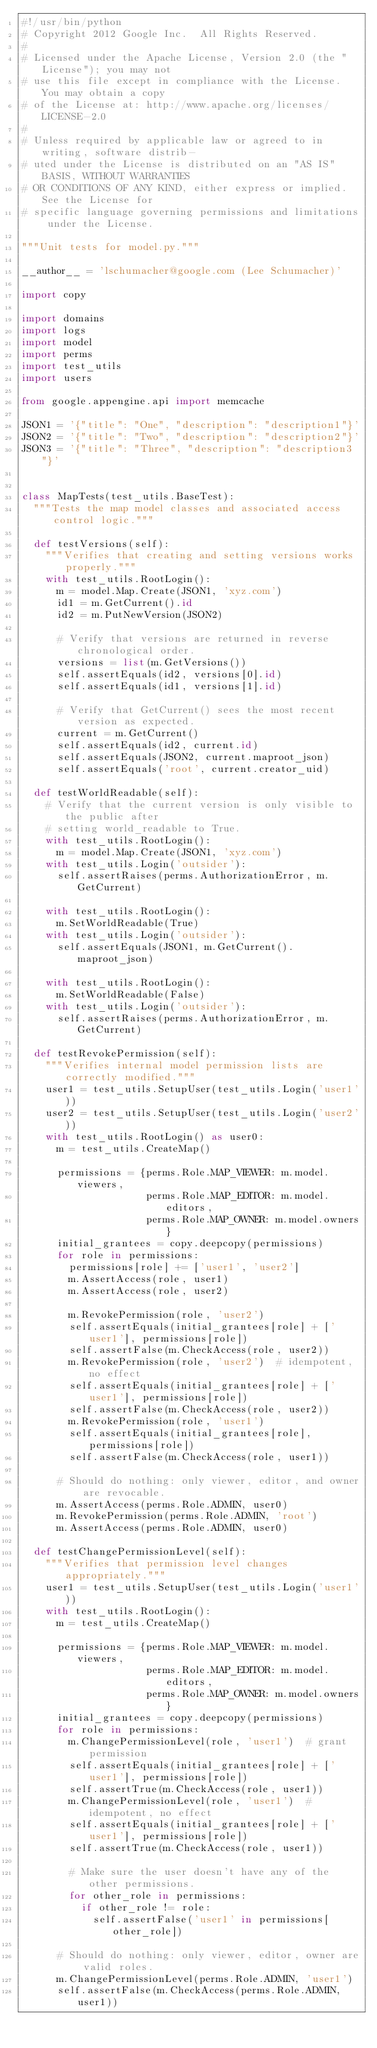<code> <loc_0><loc_0><loc_500><loc_500><_Python_>#!/usr/bin/python
# Copyright 2012 Google Inc.  All Rights Reserved.
#
# Licensed under the Apache License, Version 2.0 (the "License"); you may not
# use this file except in compliance with the License.  You may obtain a copy
# of the License at: http://www.apache.org/licenses/LICENSE-2.0
#
# Unless required by applicable law or agreed to in writing, software distrib-
# uted under the License is distributed on an "AS IS" BASIS, WITHOUT WARRANTIES
# OR CONDITIONS OF ANY KIND, either express or implied.  See the License for
# specific language governing permissions and limitations under the License.

"""Unit tests for model.py."""

__author__ = 'lschumacher@google.com (Lee Schumacher)'

import copy

import domains
import logs
import model
import perms
import test_utils
import users

from google.appengine.api import memcache

JSON1 = '{"title": "One", "description": "description1"}'
JSON2 = '{"title": "Two", "description": "description2"}'
JSON3 = '{"title": "Three", "description": "description3"}'


class MapTests(test_utils.BaseTest):
  """Tests the map model classes and associated access control logic."""

  def testVersions(self):
    """Verifies that creating and setting versions works properly."""
    with test_utils.RootLogin():
      m = model.Map.Create(JSON1, 'xyz.com')
      id1 = m.GetCurrent().id
      id2 = m.PutNewVersion(JSON2)

      # Verify that versions are returned in reverse chronological order.
      versions = list(m.GetVersions())
      self.assertEquals(id2, versions[0].id)
      self.assertEquals(id1, versions[1].id)

      # Verify that GetCurrent() sees the most recent version as expected.
      current = m.GetCurrent()
      self.assertEquals(id2, current.id)
      self.assertEquals(JSON2, current.maproot_json)
      self.assertEquals('root', current.creator_uid)

  def testWorldReadable(self):
    # Verify that the current version is only visible to the public after
    # setting world_readable to True.
    with test_utils.RootLogin():
      m = model.Map.Create(JSON1, 'xyz.com')
    with test_utils.Login('outsider'):
      self.assertRaises(perms.AuthorizationError, m.GetCurrent)

    with test_utils.RootLogin():
      m.SetWorldReadable(True)
    with test_utils.Login('outsider'):
      self.assertEquals(JSON1, m.GetCurrent().maproot_json)

    with test_utils.RootLogin():
      m.SetWorldReadable(False)
    with test_utils.Login('outsider'):
      self.assertRaises(perms.AuthorizationError, m.GetCurrent)

  def testRevokePermission(self):
    """Verifies internal model permission lists are correctly modified."""
    user1 = test_utils.SetupUser(test_utils.Login('user1'))
    user2 = test_utils.SetupUser(test_utils.Login('user2'))
    with test_utils.RootLogin() as user0:
      m = test_utils.CreateMap()

      permissions = {perms.Role.MAP_VIEWER: m.model.viewers,
                     perms.Role.MAP_EDITOR: m.model.editors,
                     perms.Role.MAP_OWNER: m.model.owners}
      initial_grantees = copy.deepcopy(permissions)
      for role in permissions:
        permissions[role] += ['user1', 'user2']
        m.AssertAccess(role, user1)
        m.AssertAccess(role, user2)

        m.RevokePermission(role, 'user2')
        self.assertEquals(initial_grantees[role] + ['user1'], permissions[role])
        self.assertFalse(m.CheckAccess(role, user2))
        m.RevokePermission(role, 'user2')  # idempotent, no effect
        self.assertEquals(initial_grantees[role] + ['user1'], permissions[role])
        self.assertFalse(m.CheckAccess(role, user2))
        m.RevokePermission(role, 'user1')
        self.assertEquals(initial_grantees[role], permissions[role])
        self.assertFalse(m.CheckAccess(role, user1))

      # Should do nothing: only viewer, editor, and owner are revocable.
      m.AssertAccess(perms.Role.ADMIN, user0)
      m.RevokePermission(perms.Role.ADMIN, 'root')
      m.AssertAccess(perms.Role.ADMIN, user0)

  def testChangePermissionLevel(self):
    """Verifies that permission level changes appropriately."""
    user1 = test_utils.SetupUser(test_utils.Login('user1'))
    with test_utils.RootLogin():
      m = test_utils.CreateMap()

      permissions = {perms.Role.MAP_VIEWER: m.model.viewers,
                     perms.Role.MAP_EDITOR: m.model.editors,
                     perms.Role.MAP_OWNER: m.model.owners}
      initial_grantees = copy.deepcopy(permissions)
      for role in permissions:
        m.ChangePermissionLevel(role, 'user1')  # grant permission
        self.assertEquals(initial_grantees[role] + ['user1'], permissions[role])
        self.assertTrue(m.CheckAccess(role, user1))
        m.ChangePermissionLevel(role, 'user1')  # idempotent, no effect
        self.assertEquals(initial_grantees[role] + ['user1'], permissions[role])
        self.assertTrue(m.CheckAccess(role, user1))

        # Make sure the user doesn't have any of the other permissions.
        for other_role in permissions:
          if other_role != role:
            self.assertFalse('user1' in permissions[other_role])

      # Should do nothing: only viewer, editor, owner are valid roles.
      m.ChangePermissionLevel(perms.Role.ADMIN, 'user1')
      self.assertFalse(m.CheckAccess(perms.Role.ADMIN, user1))
</code> 